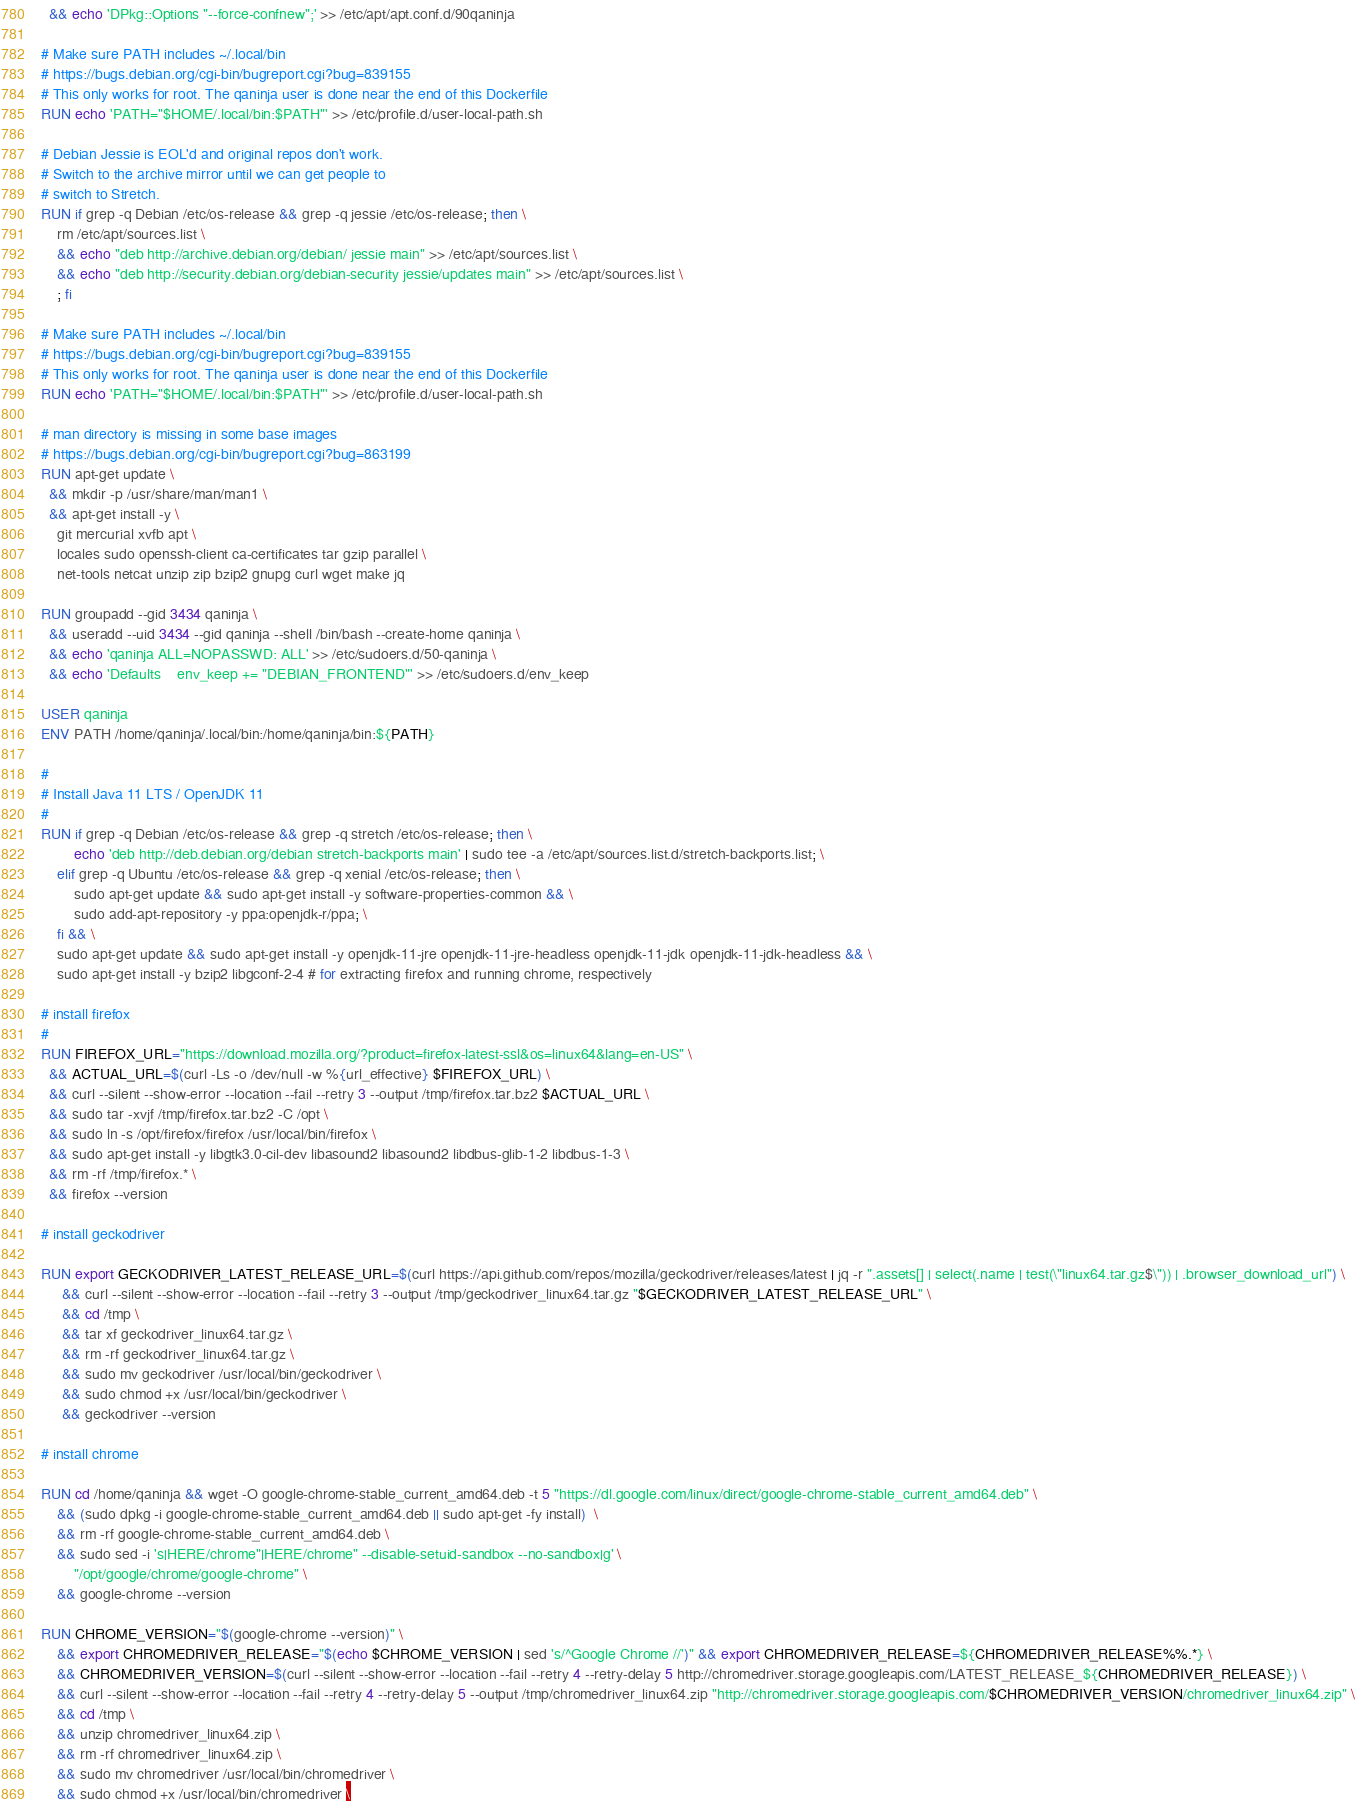Convert code to text. <code><loc_0><loc_0><loc_500><loc_500><_Dockerfile_>  && echo 'DPkg::Options "--force-confnew";' >> /etc/apt/apt.conf.d/90qaninja

# Make sure PATH includes ~/.local/bin
# https://bugs.debian.org/cgi-bin/bugreport.cgi?bug=839155
# This only works for root. The qaninja user is done near the end of this Dockerfile
RUN echo 'PATH="$HOME/.local/bin:$PATH"' >> /etc/profile.d/user-local-path.sh

# Debian Jessie is EOL'd and original repos don't work.
# Switch to the archive mirror until we can get people to
# switch to Stretch.
RUN if grep -q Debian /etc/os-release && grep -q jessie /etc/os-release; then \
	rm /etc/apt/sources.list \
    && echo "deb http://archive.debian.org/debian/ jessie main" >> /etc/apt/sources.list \
    && echo "deb http://security.debian.org/debian-security jessie/updates main" >> /etc/apt/sources.list \
	; fi

# Make sure PATH includes ~/.local/bin
# https://bugs.debian.org/cgi-bin/bugreport.cgi?bug=839155
# This only works for root. The qaninja user is done near the end of this Dockerfile
RUN echo 'PATH="$HOME/.local/bin:$PATH"' >> /etc/profile.d/user-local-path.sh

# man directory is missing in some base images
# https://bugs.debian.org/cgi-bin/bugreport.cgi?bug=863199
RUN apt-get update \
  && mkdir -p /usr/share/man/man1 \
  && apt-get install -y \
    git mercurial xvfb apt \
    locales sudo openssh-client ca-certificates tar gzip parallel \
    net-tools netcat unzip zip bzip2 gnupg curl wget make jq

RUN groupadd --gid 3434 qaninja \
  && useradd --uid 3434 --gid qaninja --shell /bin/bash --create-home qaninja \
  && echo 'qaninja ALL=NOPASSWD: ALL' >> /etc/sudoers.d/50-qaninja \
  && echo 'Defaults    env_keep += "DEBIAN_FRONTEND"' >> /etc/sudoers.d/env_keep

USER qaninja
ENV PATH /home/qaninja/.local/bin:/home/qaninja/bin:${PATH}

#
# Install Java 11 LTS / OpenJDK 11
#
RUN if grep -q Debian /etc/os-release && grep -q stretch /etc/os-release; then \
		echo 'deb http://deb.debian.org/debian stretch-backports main' | sudo tee -a /etc/apt/sources.list.d/stretch-backports.list; \
	elif grep -q Ubuntu /etc/os-release && grep -q xenial /etc/os-release; then \
		sudo apt-get update && sudo apt-get install -y software-properties-common && \
		sudo add-apt-repository -y ppa:openjdk-r/ppa; \
	fi && \
	sudo apt-get update && sudo apt-get install -y openjdk-11-jre openjdk-11-jre-headless openjdk-11-jdk openjdk-11-jdk-headless && \
	sudo apt-get install -y bzip2 libgconf-2-4 # for extracting firefox and running chrome, respectively

# install firefox
#
RUN FIREFOX_URL="https://download.mozilla.org/?product=firefox-latest-ssl&os=linux64&lang=en-US" \
  && ACTUAL_URL=$(curl -Ls -o /dev/null -w %{url_effective} $FIREFOX_URL) \
  && curl --silent --show-error --location --fail --retry 3 --output /tmp/firefox.tar.bz2 $ACTUAL_URL \
  && sudo tar -xvjf /tmp/firefox.tar.bz2 -C /opt \
  && sudo ln -s /opt/firefox/firefox /usr/local/bin/firefox \
  && sudo apt-get install -y libgtk3.0-cil-dev libasound2 libasound2 libdbus-glib-1-2 libdbus-1-3 \
  && rm -rf /tmp/firefox.* \
  && firefox --version

# install geckodriver

RUN export GECKODRIVER_LATEST_RELEASE_URL=$(curl https://api.github.com/repos/mozilla/geckodriver/releases/latest | jq -r ".assets[] | select(.name | test(\"linux64.tar.gz$\")) | .browser_download_url") \
     && curl --silent --show-error --location --fail --retry 3 --output /tmp/geckodriver_linux64.tar.gz "$GECKODRIVER_LATEST_RELEASE_URL" \
     && cd /tmp \
     && tar xf geckodriver_linux64.tar.gz \
     && rm -rf geckodriver_linux64.tar.gz \
     && sudo mv geckodriver /usr/local/bin/geckodriver \
     && sudo chmod +x /usr/local/bin/geckodriver \
     && geckodriver --version

# install chrome

RUN cd /home/qaninja && wget -O google-chrome-stable_current_amd64.deb -t 5 "https://dl.google.com/linux/direct/google-chrome-stable_current_amd64.deb" \
    && (sudo dpkg -i google-chrome-stable_current_amd64.deb || sudo apt-get -fy install)  \
    && rm -rf google-chrome-stable_current_amd64.deb \
    && sudo sed -i 's|HERE/chrome"|HERE/chrome" --disable-setuid-sandbox --no-sandbox|g' \
        "/opt/google/chrome/google-chrome" \
    && google-chrome --version

RUN CHROME_VERSION="$(google-chrome --version)" \
    && export CHROMEDRIVER_RELEASE="$(echo $CHROME_VERSION | sed 's/^Google Chrome //')" && export CHROMEDRIVER_RELEASE=${CHROMEDRIVER_RELEASE%%.*} \
    && CHROMEDRIVER_VERSION=$(curl --silent --show-error --location --fail --retry 4 --retry-delay 5 http://chromedriver.storage.googleapis.com/LATEST_RELEASE_${CHROMEDRIVER_RELEASE}) \
    && curl --silent --show-error --location --fail --retry 4 --retry-delay 5 --output /tmp/chromedriver_linux64.zip "http://chromedriver.storage.googleapis.com/$CHROMEDRIVER_VERSION/chromedriver_linux64.zip" \
    && cd /tmp \
    && unzip chromedriver_linux64.zip \
    && rm -rf chromedriver_linux64.zip \
    && sudo mv chromedriver /usr/local/bin/chromedriver \
    && sudo chmod +x /usr/local/bin/chromedriver \</code> 